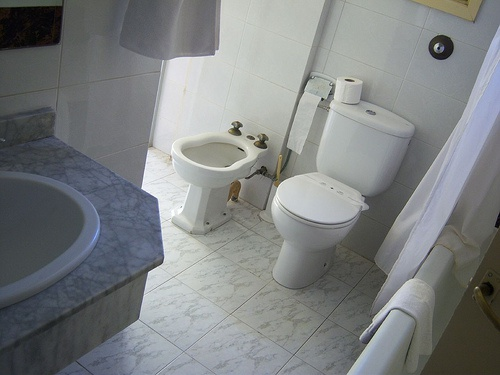Describe the objects in this image and their specific colors. I can see sink in gray and black tones, toilet in gray, darkgray, and lightgray tones, and toilet in gray, darkgray, and lightgray tones in this image. 